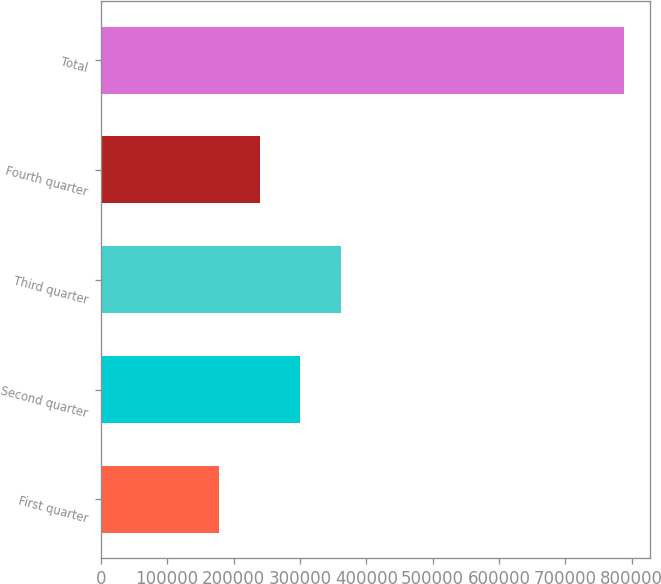Convert chart to OTSL. <chart><loc_0><loc_0><loc_500><loc_500><bar_chart><fcel>First quarter<fcel>Second quarter<fcel>Third quarter<fcel>Fourth quarter<fcel>Total<nl><fcel>178845<fcel>300563<fcel>361422<fcel>239704<fcel>787434<nl></chart> 